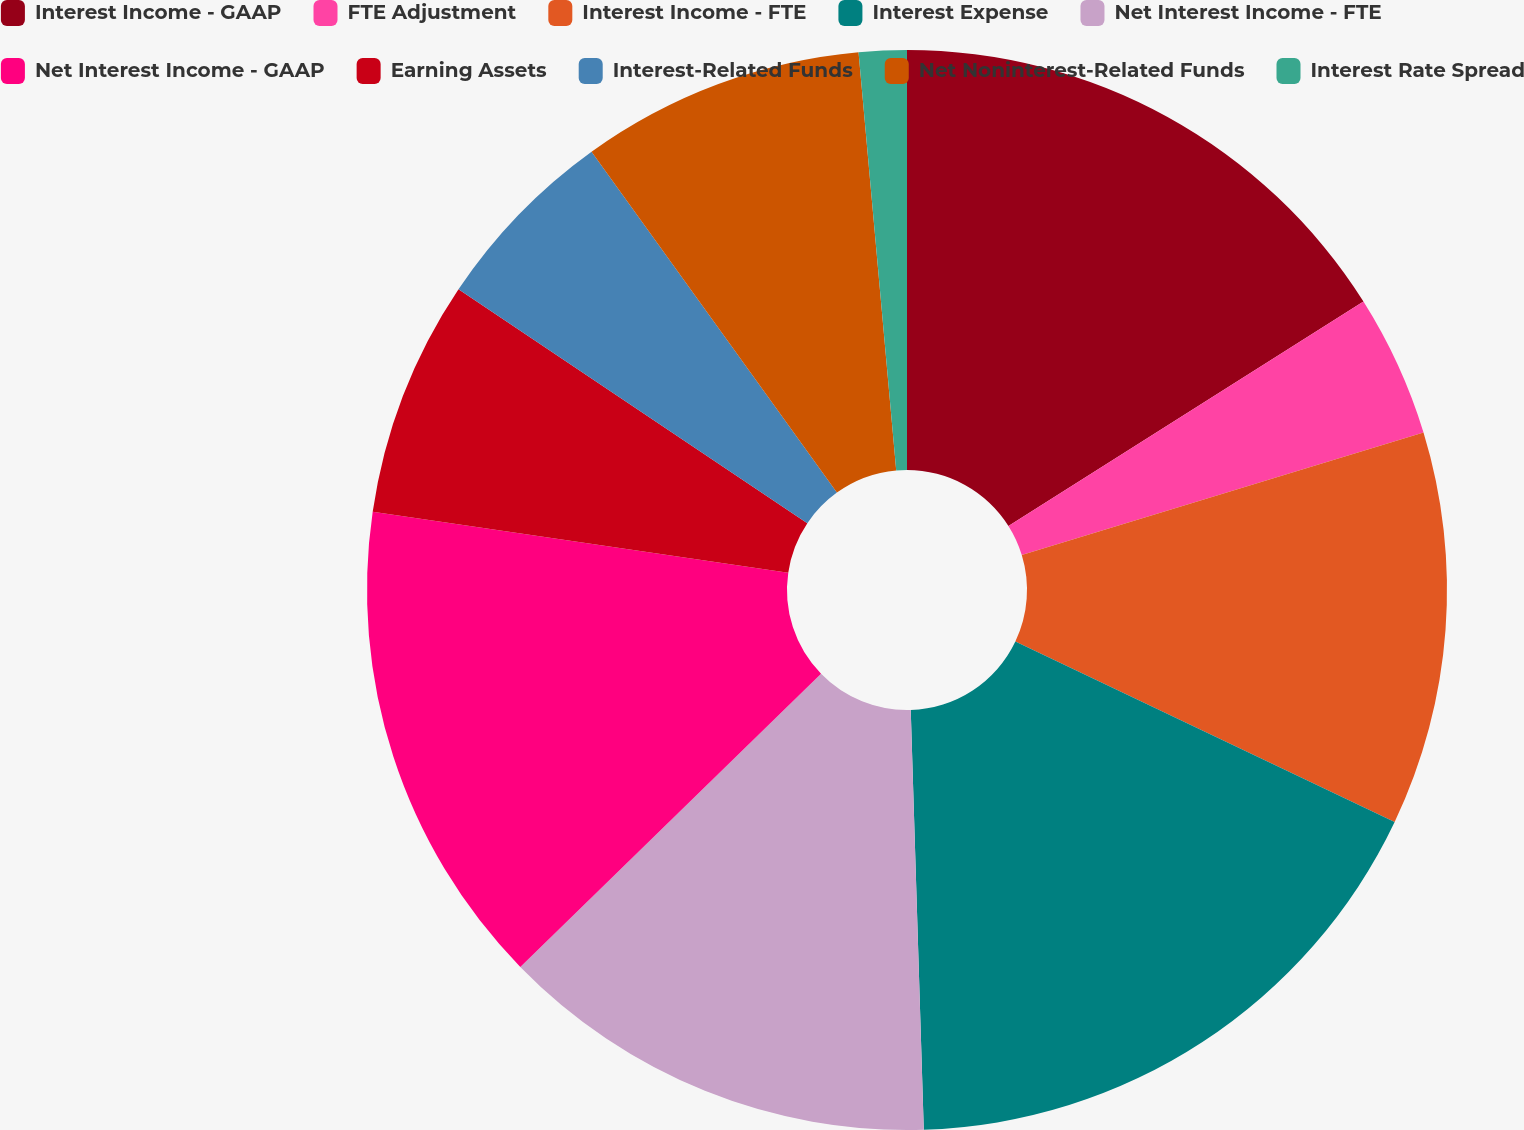<chart> <loc_0><loc_0><loc_500><loc_500><pie_chart><fcel>Interest Income - GAAP<fcel>FTE Adjustment<fcel>Interest Income - FTE<fcel>Interest Expense<fcel>Net Interest Income - FTE<fcel>Net Interest Income - GAAP<fcel>Earning Assets<fcel>Interest-Related Funds<fcel>Net Noninterest-Related Funds<fcel>Interest Rate Spread<nl><fcel>16.03%<fcel>4.26%<fcel>11.78%<fcel>17.44%<fcel>13.2%<fcel>14.61%<fcel>7.09%<fcel>5.67%<fcel>8.5%<fcel>1.43%<nl></chart> 